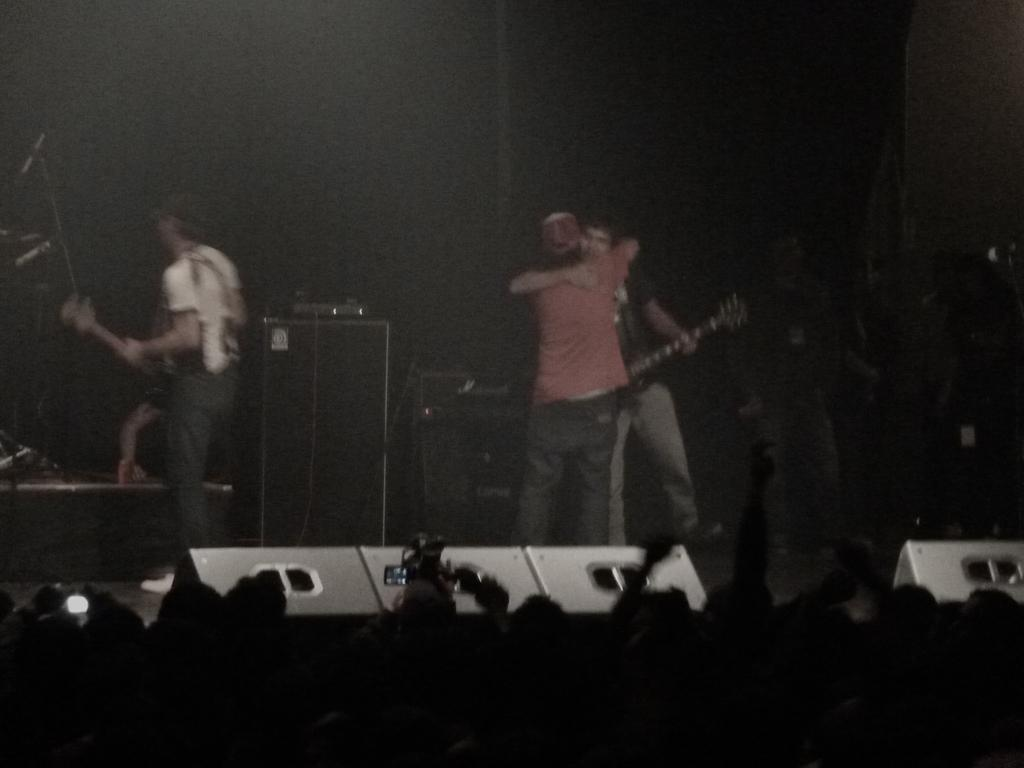What are the men on stage doing? The men on stage are playing guitar. What can be seen in the background of the image? There is a big crowd opposite the stage. What are some people in the crowd doing? Some people in the crowd are holding cameras. What are the people with cameras doing? The people with cameras are capturing images of the men on stage. What type of education can be seen on the calendar in the image? There is no calendar present in the image, so it is not possible to determine what type of education might be on it. 